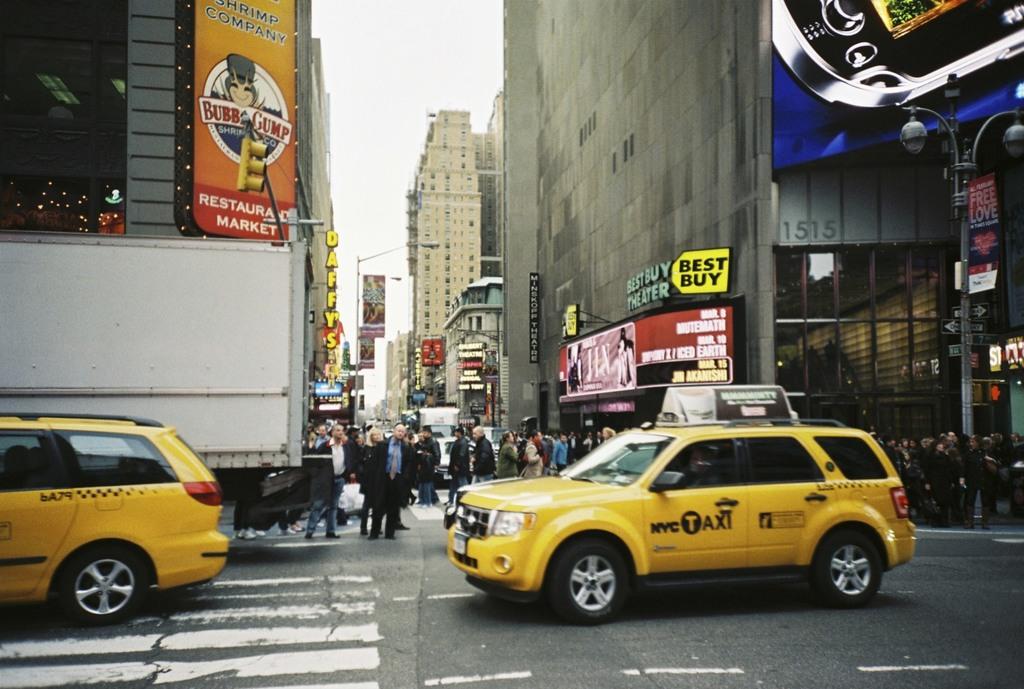What city is this taxi for?
Give a very brief answer. Nyc. 